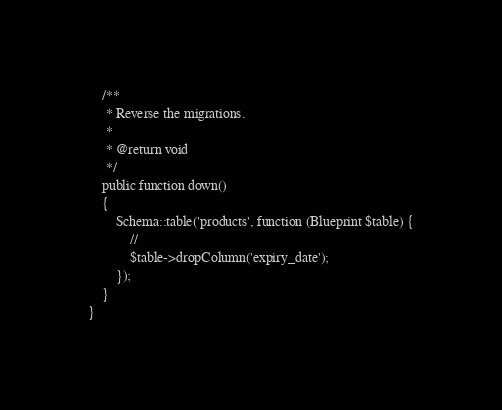Convert code to text. <code><loc_0><loc_0><loc_500><loc_500><_PHP_>
    /**
     * Reverse the migrations.
     *
     * @return void
     */
    public function down()
    {
        Schema::table('products', function (Blueprint $table) {
            //
            $table->dropColumn('expiry_date');
        });
    }
}
</code> 